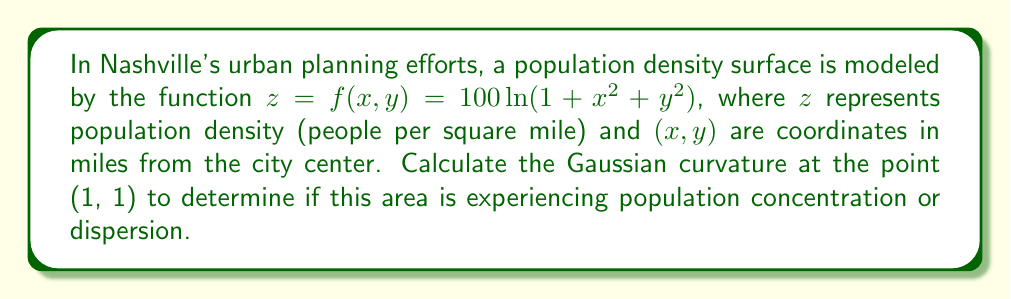Provide a solution to this math problem. To find the Gaussian curvature, we need to calculate the first and second fundamental forms.

Step 1: Calculate partial derivatives
$f_x = \frac{200x}{1+x^2+y^2}$
$f_y = \frac{200y}{1+x^2+y^2}$
$f_{xx} = \frac{200(1+y^2-x^2)}{(1+x^2+y^2)^2}$
$f_{yy} = \frac{200(1+x^2-y^2)}{(1+x^2+y^2)^2}$
$f_{xy} = f_{yx} = -\frac{400xy}{(1+x^2+y^2)^2}$

Step 2: Calculate components of the first fundamental form
$E = 1 + f_x^2 = 1 + \frac{40000x^2}{(1+x^2+y^2)^2}$
$F = f_x f_y = \frac{40000xy}{(1+x^2+y^2)^2}$
$G = 1 + f_y^2 = 1 + \frac{40000y^2}{(1+x^2+y^2)^2}$

Step 3: Calculate components of the second fundamental form
$e = \frac{f_{xx}}{\sqrt{1+f_x^2+f_y^2}} = \frac{200(1+y^2-x^2)}{(1+x^2+y^2)^2\sqrt{1+\frac{40000(x^2+y^2)}{(1+x^2+y^2)^2}}}$
$f = \frac{f_{xy}}{\sqrt{1+f_x^2+f_y^2}} = -\frac{400xy}{(1+x^2+y^2)^2\sqrt{1+\frac{40000(x^2+y^2)}{(1+x^2+y^2)^2}}}$
$g = \frac{f_{yy}}{\sqrt{1+f_x^2+f_y^2}} = \frac{200(1+x^2-y^2)}{(1+x^2+y^2)^2\sqrt{1+\frac{40000(x^2+y^2)}{(1+x^2+y^2)^2}}}$

Step 4: Calculate Gaussian curvature
$K = \frac{eg-f^2}{EG-F^2}$

Step 5: Evaluate at point (1, 1)
Substituting x = 1 and y = 1 into the expressions for e, f, g, E, F, and G:

$e = \frac{200}{9\sqrt{1001}}$
$f = -\frac{400}{9\sqrt{1001}}$
$g = \frac{200}{9\sqrt{1001}}$
$E = G = 1 + \frac{10000}{9}$
$F = \frac{10000}{9}$

Step 6: Calculate final Gaussian curvature
$K = \frac{(\frac{200}{9\sqrt{1001}})(\frac{200}{9\sqrt{1001}}) - (-\frac{400}{9\sqrt{1001}})^2}{(1 + \frac{10000}{9})(1 + \frac{10000}{9}) - (\frac{10000}{9})^2}$

$K = \frac{0}{10001} = 0$
Answer: $K = 0$ 